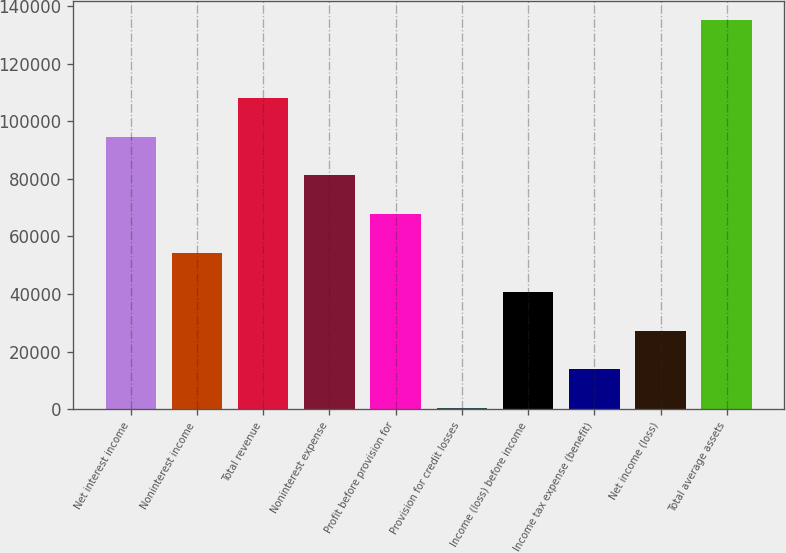<chart> <loc_0><loc_0><loc_500><loc_500><bar_chart><fcel>Net interest income<fcel>Noninterest income<fcel>Total revenue<fcel>Noninterest expense<fcel>Profit before provision for<fcel>Provision for credit losses<fcel>Income (loss) before income<fcel>Income tax expense (benefit)<fcel>Net income (loss)<fcel>Total average assets<nl><fcel>94639.6<fcel>54209.2<fcel>108116<fcel>81162.8<fcel>67686<fcel>302<fcel>40732.4<fcel>13778.8<fcel>27255.6<fcel>135070<nl></chart> 